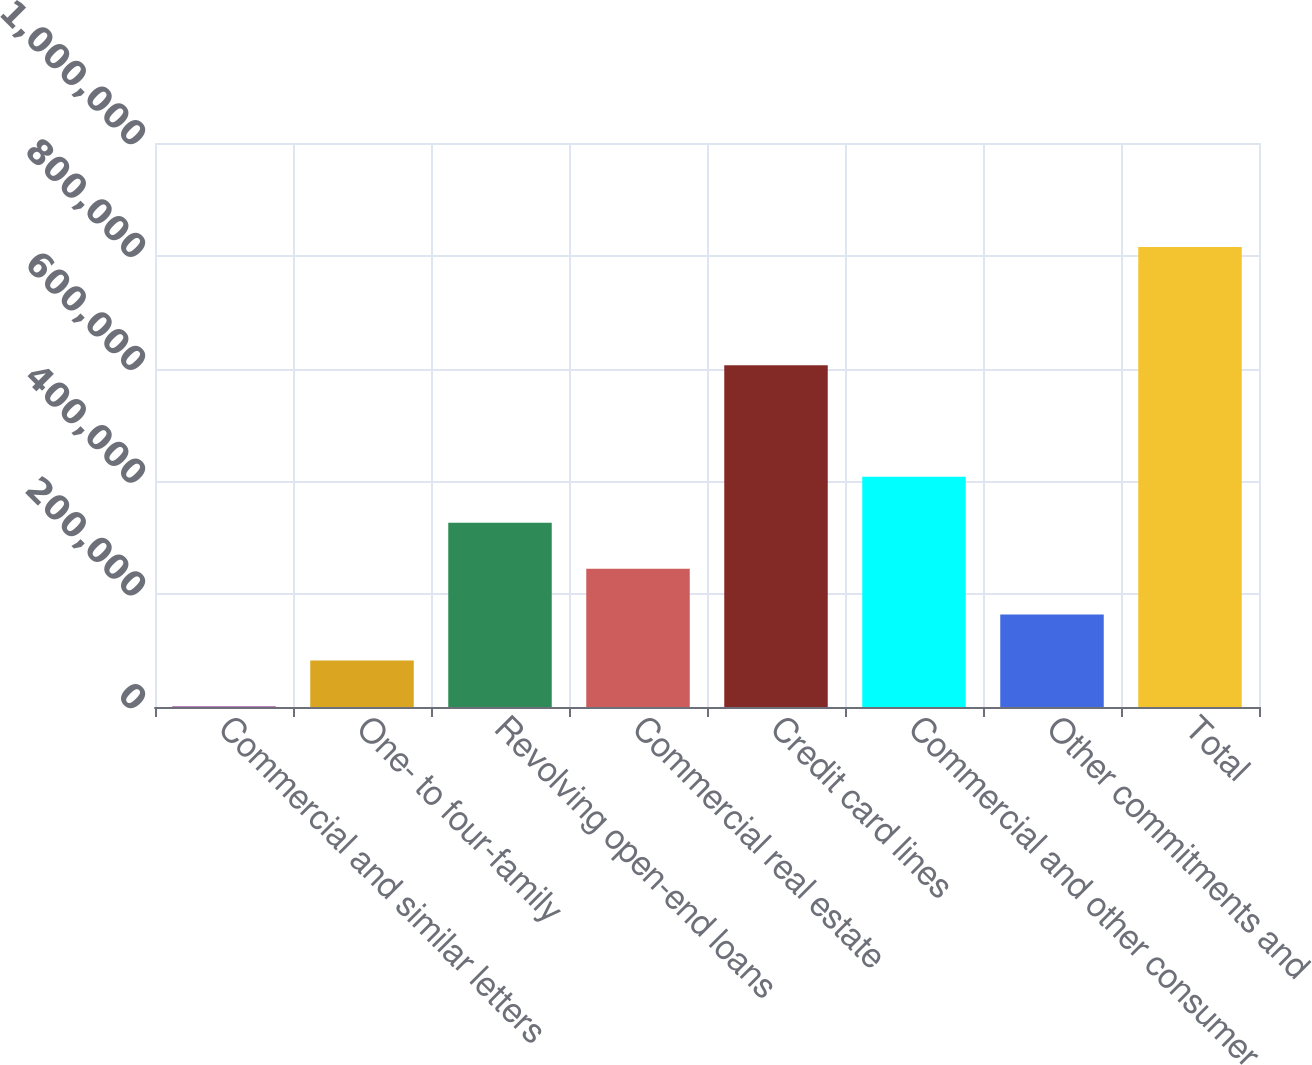<chart> <loc_0><loc_0><loc_500><loc_500><bar_chart><fcel>Commercial and similar letters<fcel>One- to four-family<fcel>Revolving open-end loans<fcel>Commercial real estate<fcel>Credit card lines<fcel>Commercial and other consumer<fcel>Other commitments and<fcel>Total<nl><fcel>823<fcel>82313.6<fcel>326785<fcel>245295<fcel>605857<fcel>408276<fcel>163804<fcel>815729<nl></chart> 